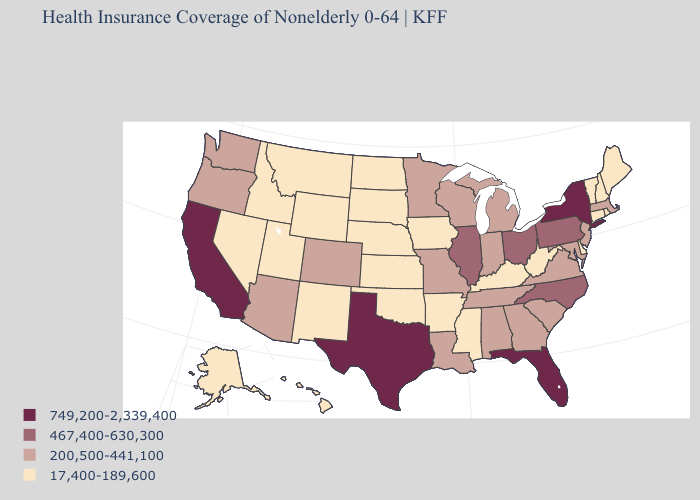How many symbols are there in the legend?
Be succinct. 4. Does the first symbol in the legend represent the smallest category?
Answer briefly. No. Name the states that have a value in the range 749,200-2,339,400?
Be succinct. California, Florida, New York, Texas. Name the states that have a value in the range 17,400-189,600?
Answer briefly. Alaska, Arkansas, Connecticut, Delaware, Hawaii, Idaho, Iowa, Kansas, Kentucky, Maine, Mississippi, Montana, Nebraska, Nevada, New Hampshire, New Mexico, North Dakota, Oklahoma, Rhode Island, South Dakota, Utah, Vermont, West Virginia, Wyoming. What is the value of Iowa?
Give a very brief answer. 17,400-189,600. What is the value of Massachusetts?
Be succinct. 200,500-441,100. Does New Hampshire have the same value as Indiana?
Quick response, please. No. Among the states that border Wyoming , does Montana have the highest value?
Quick response, please. No. What is the value of New Hampshire?
Concise answer only. 17,400-189,600. What is the value of New Hampshire?
Quick response, please. 17,400-189,600. Does Vermont have a lower value than Georgia?
Give a very brief answer. Yes. Does the map have missing data?
Write a very short answer. No. Does Texas have the highest value in the South?
Keep it brief. Yes. Does Idaho have the lowest value in the USA?
Be succinct. Yes. Does the first symbol in the legend represent the smallest category?
Give a very brief answer. No. 